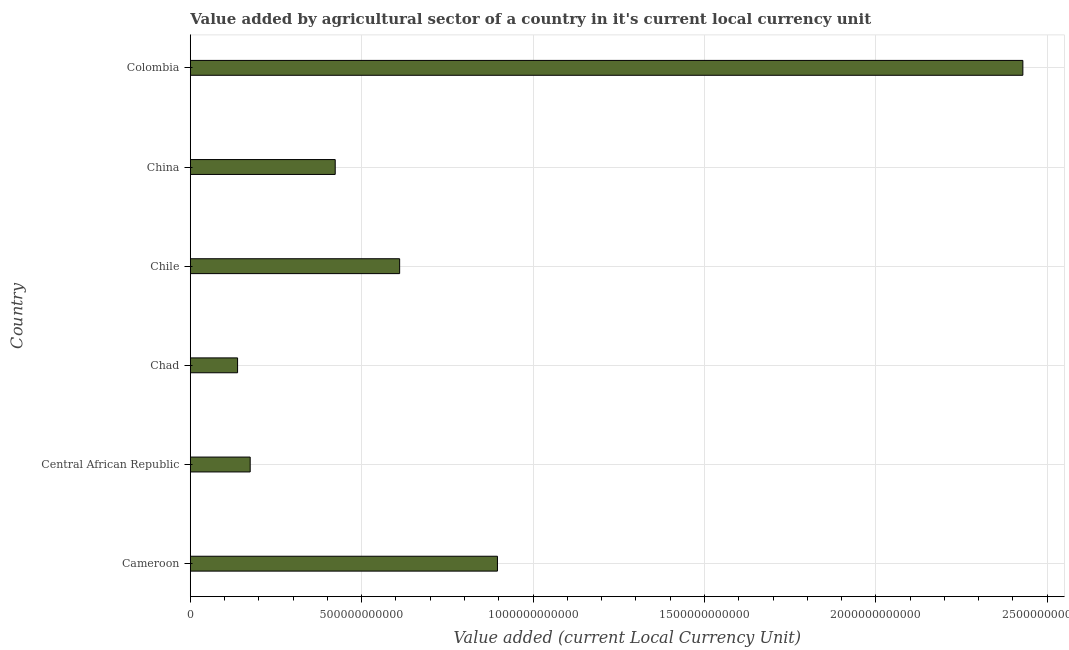Does the graph contain any zero values?
Keep it short and to the point. No. What is the title of the graph?
Your answer should be very brief. Value added by agricultural sector of a country in it's current local currency unit. What is the label or title of the X-axis?
Keep it short and to the point. Value added (current Local Currency Unit). What is the label or title of the Y-axis?
Keep it short and to the point. Country. What is the value added by agriculture sector in Chad?
Ensure brevity in your answer.  1.38e+11. Across all countries, what is the maximum value added by agriculture sector?
Make the answer very short. 2.43e+12. Across all countries, what is the minimum value added by agriculture sector?
Keep it short and to the point. 1.38e+11. In which country was the value added by agriculture sector maximum?
Offer a very short reply. Colombia. In which country was the value added by agriculture sector minimum?
Give a very brief answer. Chad. What is the sum of the value added by agriculture sector?
Ensure brevity in your answer.  4.67e+12. What is the difference between the value added by agriculture sector in Cameroon and China?
Your answer should be compact. 4.73e+11. What is the average value added by agriculture sector per country?
Ensure brevity in your answer.  7.79e+11. What is the median value added by agriculture sector?
Offer a terse response. 5.17e+11. What is the ratio of the value added by agriculture sector in Cameroon to that in China?
Offer a terse response. 2.12. Is the value added by agriculture sector in Cameroon less than that in Colombia?
Provide a succinct answer. Yes. What is the difference between the highest and the second highest value added by agriculture sector?
Offer a very short reply. 1.53e+12. Is the sum of the value added by agriculture sector in Chad and Colombia greater than the maximum value added by agriculture sector across all countries?
Offer a terse response. Yes. What is the difference between the highest and the lowest value added by agriculture sector?
Provide a short and direct response. 2.29e+12. Are all the bars in the graph horizontal?
Give a very brief answer. Yes. What is the difference between two consecutive major ticks on the X-axis?
Your answer should be very brief. 5.00e+11. What is the Value added (current Local Currency Unit) in Cameroon?
Your response must be concise. 8.96e+11. What is the Value added (current Local Currency Unit) in Central African Republic?
Give a very brief answer. 1.75e+11. What is the Value added (current Local Currency Unit) in Chad?
Offer a very short reply. 1.38e+11. What is the Value added (current Local Currency Unit) of Chile?
Offer a terse response. 6.11e+11. What is the Value added (current Local Currency Unit) in China?
Keep it short and to the point. 4.23e+11. What is the Value added (current Local Currency Unit) in Colombia?
Provide a short and direct response. 2.43e+12. What is the difference between the Value added (current Local Currency Unit) in Cameroon and Central African Republic?
Provide a succinct answer. 7.21e+11. What is the difference between the Value added (current Local Currency Unit) in Cameroon and Chad?
Offer a very short reply. 7.58e+11. What is the difference between the Value added (current Local Currency Unit) in Cameroon and Chile?
Your answer should be very brief. 2.85e+11. What is the difference between the Value added (current Local Currency Unit) in Cameroon and China?
Provide a short and direct response. 4.73e+11. What is the difference between the Value added (current Local Currency Unit) in Cameroon and Colombia?
Ensure brevity in your answer.  -1.53e+12. What is the difference between the Value added (current Local Currency Unit) in Central African Republic and Chad?
Give a very brief answer. 3.68e+1. What is the difference between the Value added (current Local Currency Unit) in Central African Republic and Chile?
Provide a succinct answer. -4.36e+11. What is the difference between the Value added (current Local Currency Unit) in Central African Republic and China?
Your response must be concise. -2.48e+11. What is the difference between the Value added (current Local Currency Unit) in Central African Republic and Colombia?
Keep it short and to the point. -2.25e+12. What is the difference between the Value added (current Local Currency Unit) in Chad and Chile?
Offer a terse response. -4.73e+11. What is the difference between the Value added (current Local Currency Unit) in Chad and China?
Offer a terse response. -2.85e+11. What is the difference between the Value added (current Local Currency Unit) in Chad and Colombia?
Keep it short and to the point. -2.29e+12. What is the difference between the Value added (current Local Currency Unit) in Chile and China?
Provide a short and direct response. 1.88e+11. What is the difference between the Value added (current Local Currency Unit) in Chile and Colombia?
Give a very brief answer. -1.82e+12. What is the difference between the Value added (current Local Currency Unit) in China and Colombia?
Keep it short and to the point. -2.01e+12. What is the ratio of the Value added (current Local Currency Unit) in Cameroon to that in Central African Republic?
Ensure brevity in your answer.  5.13. What is the ratio of the Value added (current Local Currency Unit) in Cameroon to that in Chad?
Offer a very short reply. 6.5. What is the ratio of the Value added (current Local Currency Unit) in Cameroon to that in Chile?
Ensure brevity in your answer.  1.47. What is the ratio of the Value added (current Local Currency Unit) in Cameroon to that in China?
Offer a very short reply. 2.12. What is the ratio of the Value added (current Local Currency Unit) in Cameroon to that in Colombia?
Your response must be concise. 0.37. What is the ratio of the Value added (current Local Currency Unit) in Central African Republic to that in Chad?
Offer a terse response. 1.27. What is the ratio of the Value added (current Local Currency Unit) in Central African Republic to that in Chile?
Offer a very short reply. 0.29. What is the ratio of the Value added (current Local Currency Unit) in Central African Republic to that in China?
Your answer should be compact. 0.41. What is the ratio of the Value added (current Local Currency Unit) in Central African Republic to that in Colombia?
Provide a succinct answer. 0.07. What is the ratio of the Value added (current Local Currency Unit) in Chad to that in Chile?
Your answer should be compact. 0.23. What is the ratio of the Value added (current Local Currency Unit) in Chad to that in China?
Ensure brevity in your answer.  0.33. What is the ratio of the Value added (current Local Currency Unit) in Chad to that in Colombia?
Make the answer very short. 0.06. What is the ratio of the Value added (current Local Currency Unit) in Chile to that in China?
Offer a very short reply. 1.44. What is the ratio of the Value added (current Local Currency Unit) in Chile to that in Colombia?
Your answer should be very brief. 0.25. What is the ratio of the Value added (current Local Currency Unit) in China to that in Colombia?
Your answer should be very brief. 0.17. 